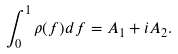Convert formula to latex. <formula><loc_0><loc_0><loc_500><loc_500>\int _ { 0 } ^ { 1 } \rho ( f ) d f = A _ { 1 } + i A _ { 2 } .</formula> 